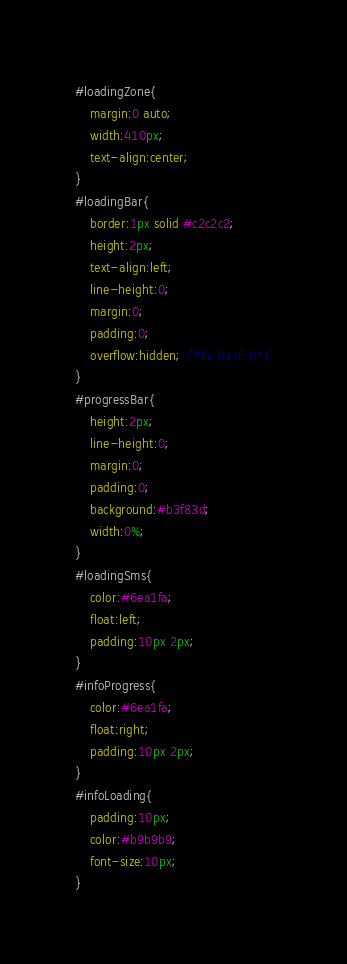<code> <loc_0><loc_0><loc_500><loc_500><_CSS_>#loadingZone{
    margin:0 auto;
    width:410px;
    text-align:center;
}
#loadingBar{
    border:1px solid #c2c2c2;
    height:2px;
    text-align:left;
    line-height:0;
    margin:0;
    padding:0;
    overflow:hidden; /*fix for IE 6*/
}
#progressBar{
    height:2px;
    line-height:0;
    margin:0;
    padding:0;
    background:#b3f83d;
    width:0%;
}
#loadingSms{
    color:#6ea1fa;
    float:left;
    padding:10px 2px;
}
#infoProgress{
    color:#6ea1fa;
    float:right;
    padding:10px 2px;
}
#infoLoading{
    padding:10px;
    color:#b9b9b9;
    font-size:10px;
}</code> 